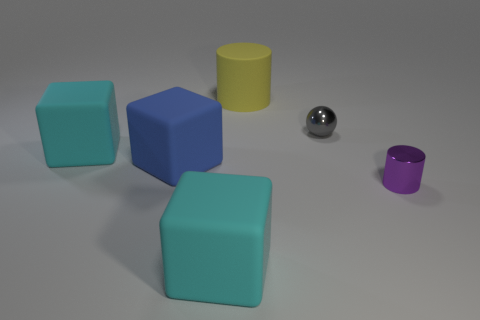Add 3 shiny balls. How many objects exist? 9 Subtract all cyan cubes. How many were subtracted if there are1cyan cubes left? 1 Subtract 1 spheres. How many spheres are left? 0 Subtract all gray cylinders. Subtract all blue blocks. How many cylinders are left? 2 Subtract all purple spheres. How many blue blocks are left? 1 Subtract all cyan objects. Subtract all blue cubes. How many objects are left? 3 Add 1 purple cylinders. How many purple cylinders are left? 2 Add 2 yellow cylinders. How many yellow cylinders exist? 3 Subtract all yellow cylinders. How many cylinders are left? 1 Subtract all big cyan rubber cubes. How many cubes are left? 1 